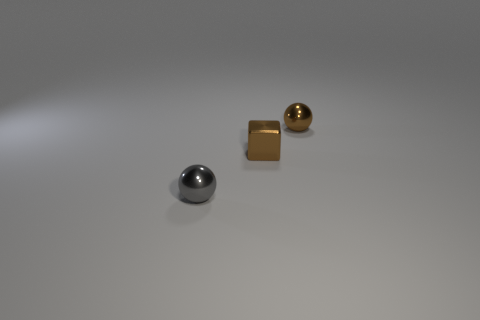There is a tiny ball on the right side of the small metal ball that is in front of the small sphere behind the small gray ball; what is its material?
Offer a very short reply. Metal. Is the number of brown matte cubes greater than the number of gray objects?
Your response must be concise. No. Is there any other thing of the same color as the cube?
Offer a very short reply. Yes. What is the size of the brown ball that is made of the same material as the small brown cube?
Provide a short and direct response. Small. What material is the cube?
Provide a succinct answer. Metal. What number of cyan rubber balls are the same size as the metallic cube?
Your response must be concise. 0. There is a small shiny object that is the same color as the block; what is its shape?
Your answer should be very brief. Sphere. Are there any brown objects of the same shape as the gray metal object?
Keep it short and to the point. Yes. There is another sphere that is the same size as the brown shiny ball; what is its color?
Give a very brief answer. Gray. There is a tiny metallic ball that is in front of the ball to the right of the small gray metal sphere; what color is it?
Provide a short and direct response. Gray. 